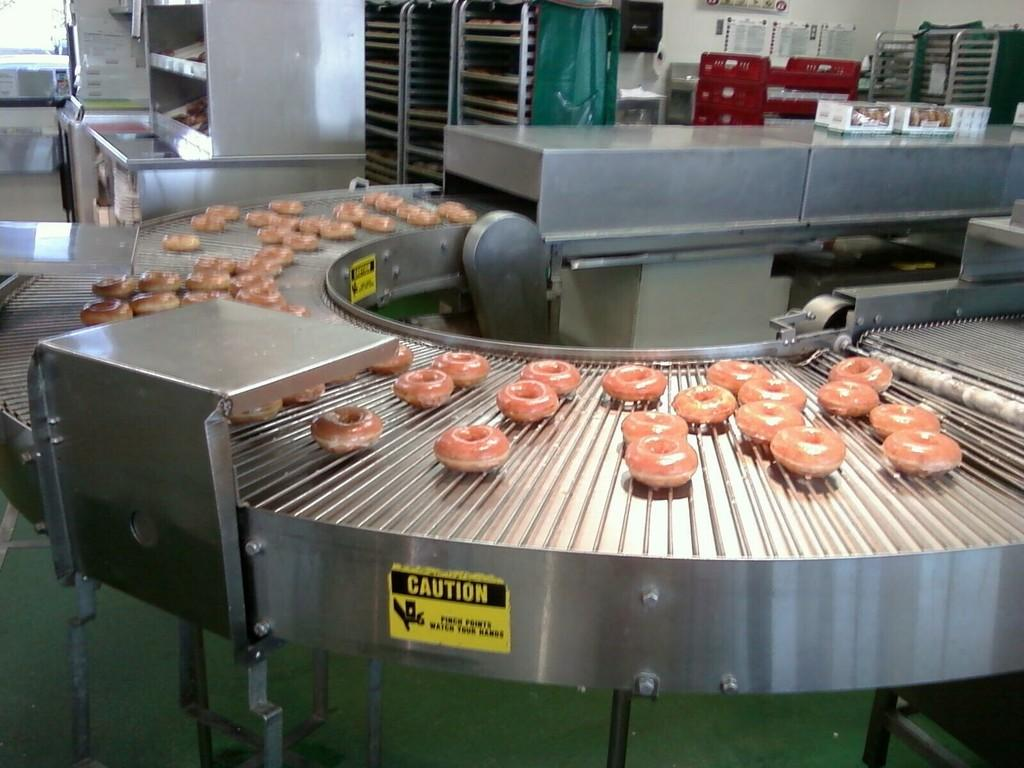<image>
Provide a brief description of the given image. a caution sign on the side of a donut machine 